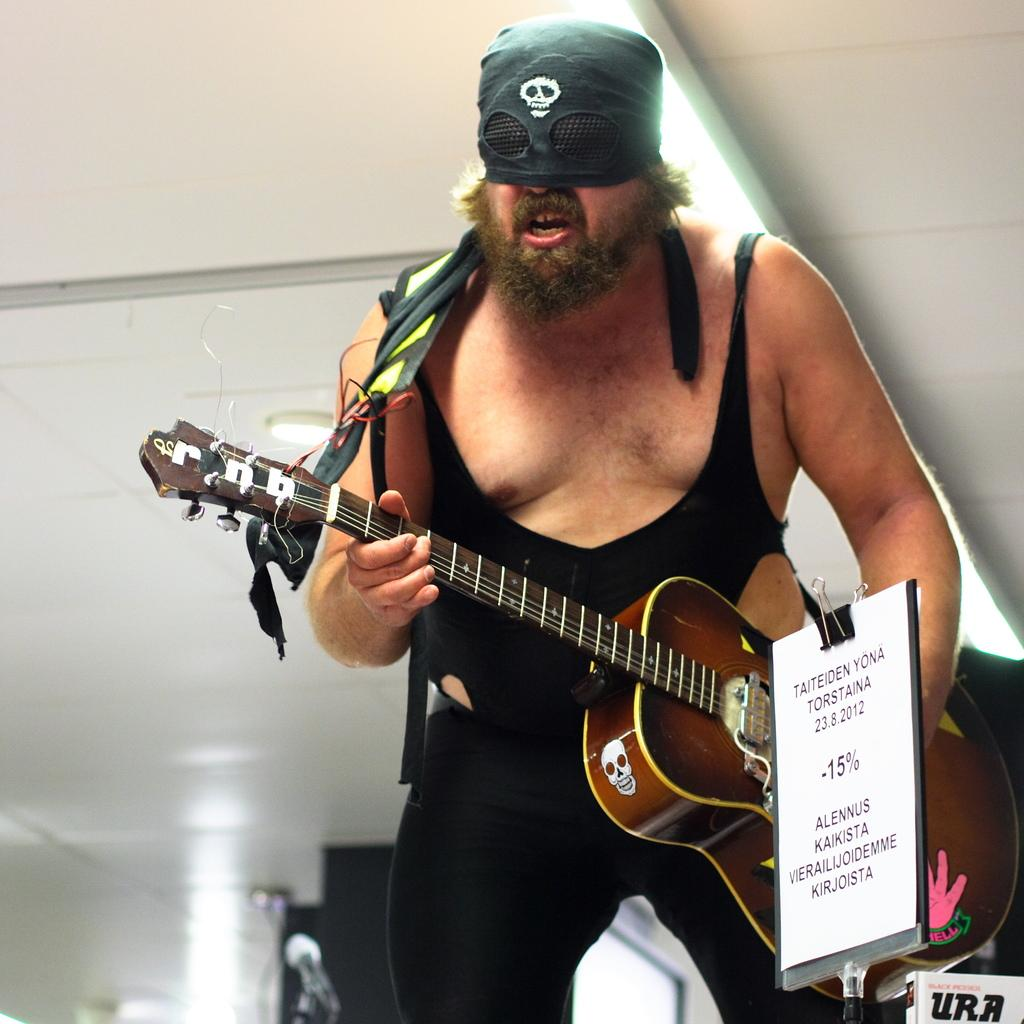What is the man in the image doing? The man is playing a guitar in the image. What is the man wearing on his face? The man is wearing a mask over his face. What object can be seen with a clip attached to it? There is a board with a clip in the image. What type of lighting is visible in the image? There is a ceiling with lights visible in the image. What device is present for amplifying sound? There is a microphone in the image. What type of religious ceremony is taking place in the image? There is no indication of a religious ceremony in the image; it features a man playing a guitar while wearing a mask. Can you see any planes in the image? No, there are no planes visible in the image. 